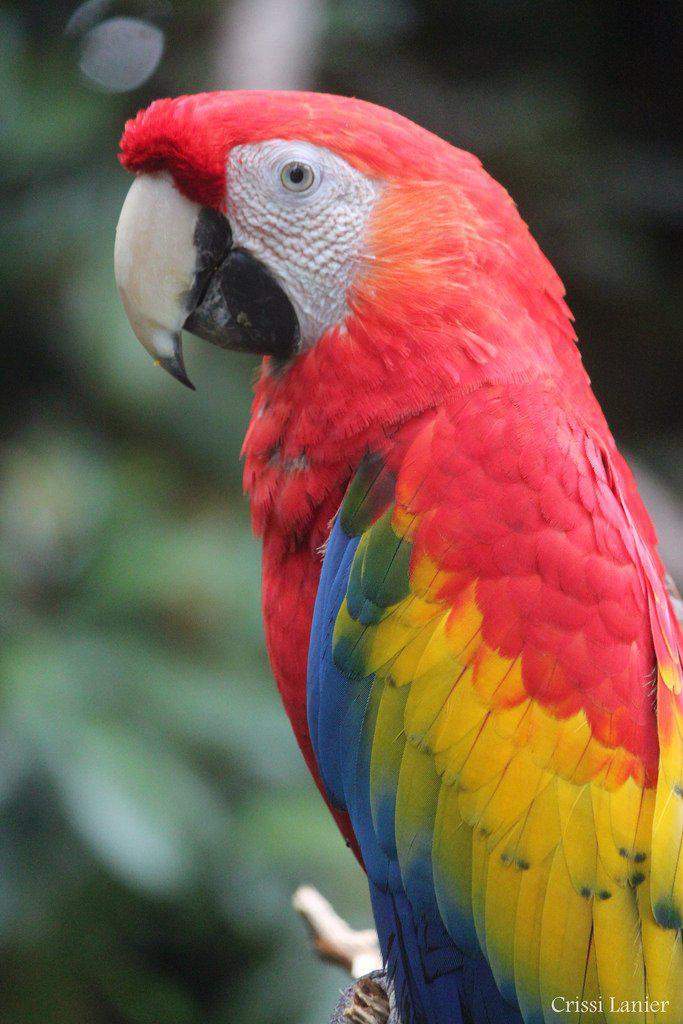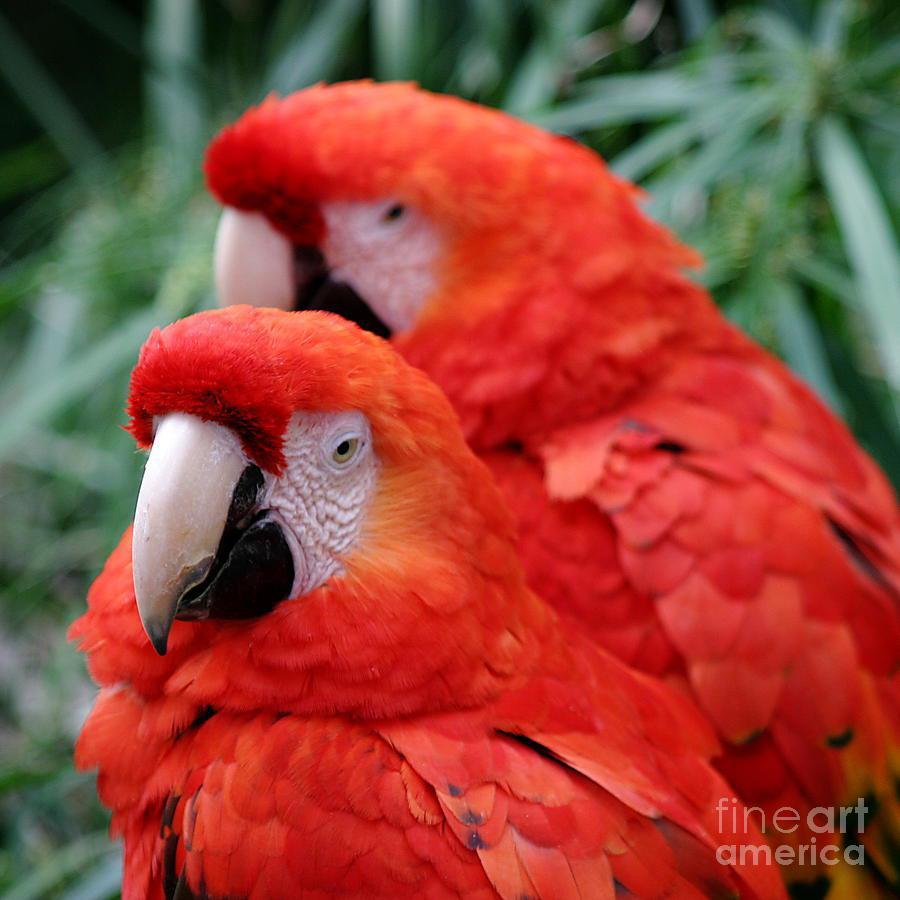The first image is the image on the left, the second image is the image on the right. Considering the images on both sides, is "There are three parrots" valid? Answer yes or no. Yes. The first image is the image on the left, the second image is the image on the right. Examine the images to the left and right. Is the description "Three parrots have red feathered heads and white beaks." accurate? Answer yes or no. Yes. 